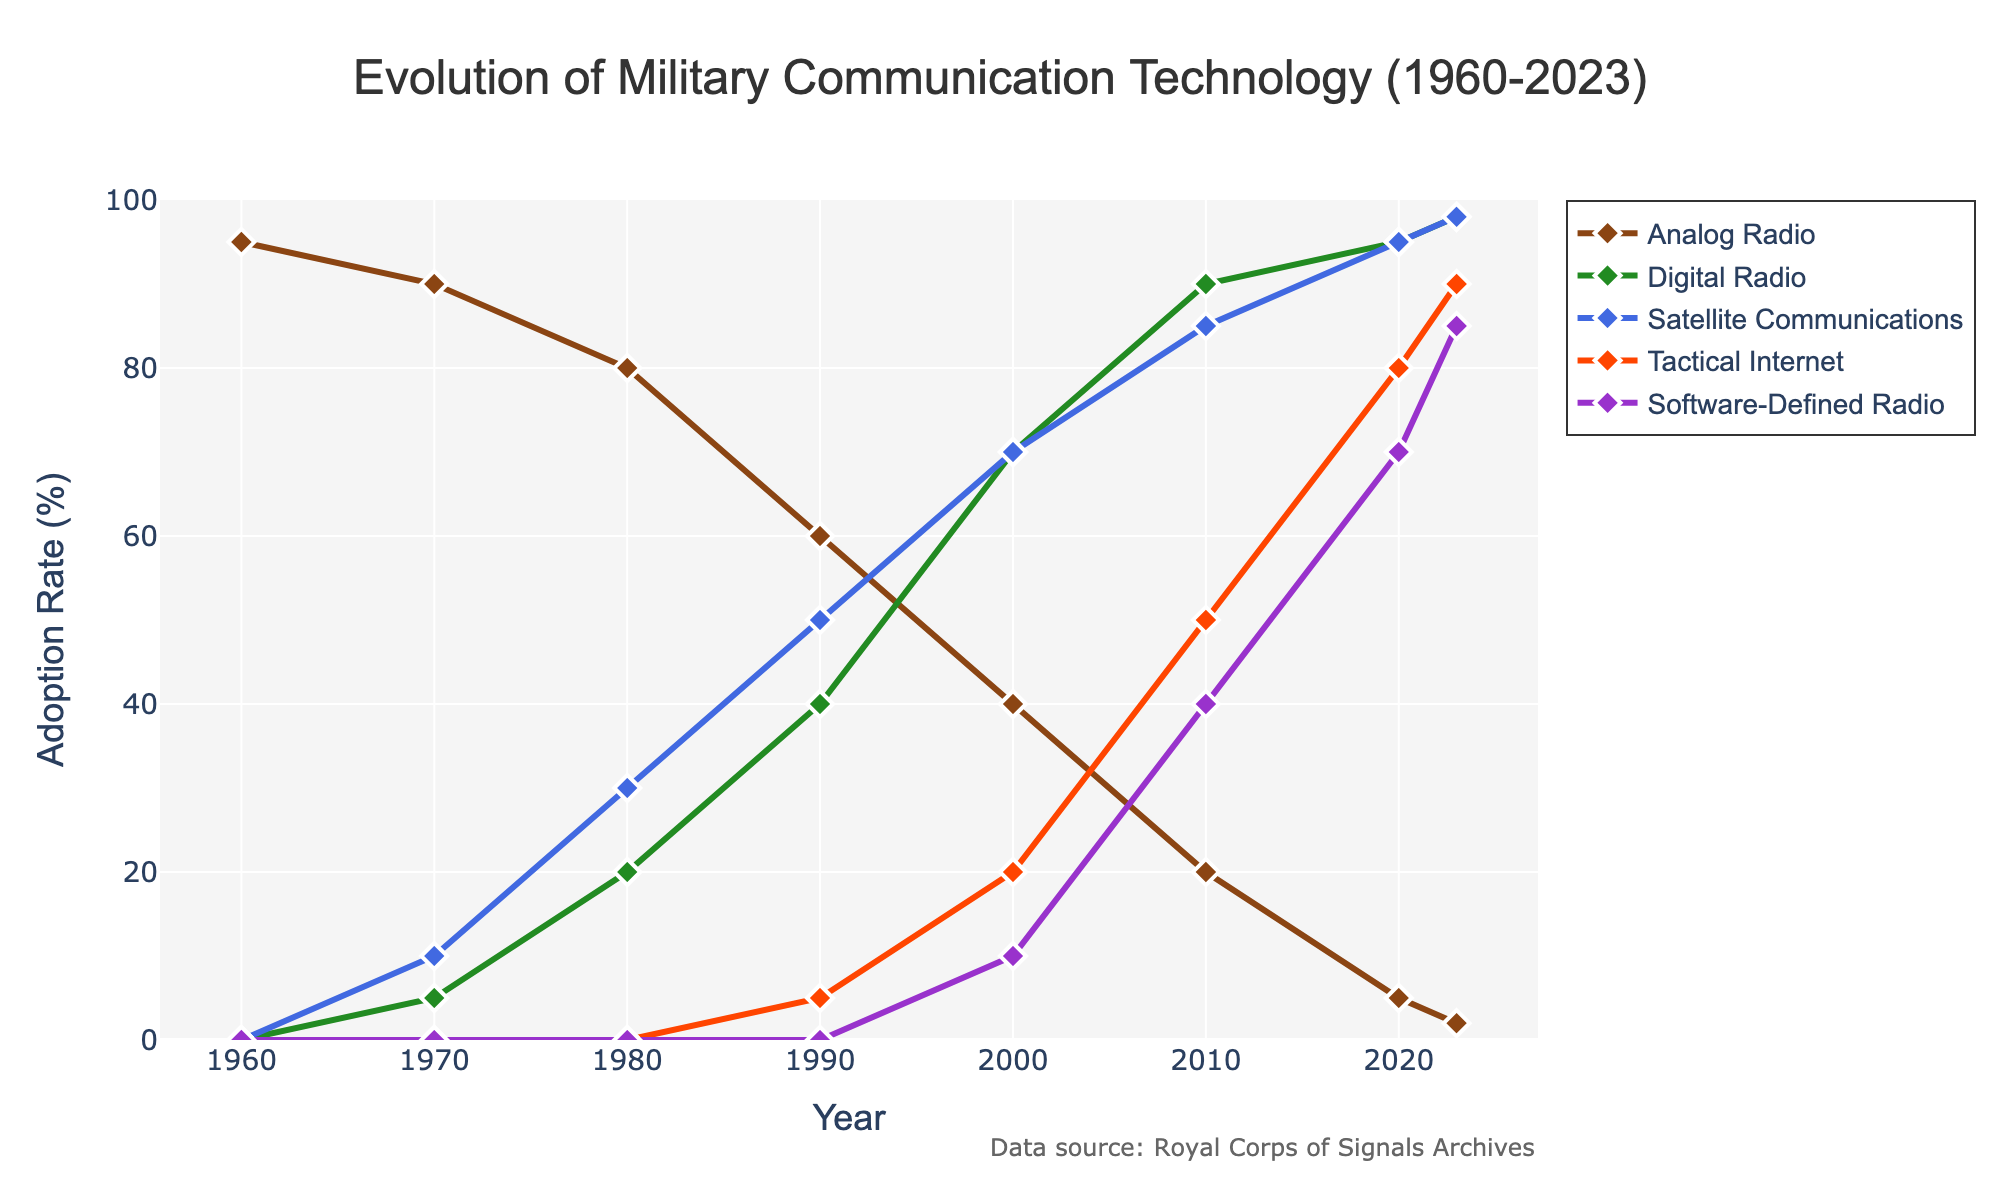What was the adoption rate of Analog Radio in 1980? To find the adoption rate of Analog Radio in 1980, locate the year 1980 on the x-axis and follow the line representing Analog Radio. The value at this point is 80%.
Answer: 80% Which communication technology had the highest adoption rate by 2023? To determine which technology had the highest adoption rate by 2023, look at the end of the lines in 2023. Both Satellite Communications and Digital Radio have the highest adoption rates at 98%.
Answer: Satellite Communications and Digital Radio Between which two consecutive decades did Satellite Communications see the biggest increase in adoption rate? To identify the biggest increase, look at the y-values for Satellite Communications from decade to decade. The largest jump is between 1970 (10%) and 1980 (30%), which is a 20% increase.
Answer: 1970 and 1980 Compare the adoption rates of Tactical Internet and Software-Defined Radio in 2010. Which one was more widely adopted? In 2010, find the lines representing Tactical Internet and Software-Defined Radio and see their y-values. Tactical Internet has a 50% adoption rate, whereas Software-Defined Radio has a 40% adoption rate. Therefore, Tactical Internet was more widely adopted.
Answer: Tactical Internet By what percentage did the adoption rate of Digital Radio increase from 2000 to 2010? To find the percentage increase from 2000 to 2010, subtract the 2000 value from the 2010 value for Digital Radio: 90% - 70% = 20%.
Answer: 20% What was the combined adoption rate of Analog Radio and Satellite Communications in 2000? Add the adoption rates of Analog Radio (40%) and Satellite Communications (70%) in 2000: 40% + 70% = 110%.
Answer: 110% Did any technology surpass the 50% adoption rate by 1990? If so, which one(s)? To check if any technology surpassed the 50% rate by 1990, look at the y-values of all technologies in 1990. Both Satellite Communications (50%) exactly reached 50% but Digital Radio (40%) and Analog Radio (60%) surpassed 50%. However, only Analog Radio clearly surpassed it.
Answer: Analog Radio How does the decline in Analog Radio adoption compare between 1960 and 2020? To determine the decline, subtract the 2020 value from the 1960 value: 95% - 5% = 90%. Therefore, Analog Radio adoption declined by 90%.
Answer: 90% Which technology saw a steady increase in adoption each decade from 1960 to 2023? To identify a steady increase, look for a line that continuously rises without decline. Digital Radio shows a steady increase from 1960 (0%) to 2023 (98%).
Answer: Digital Radio What is the adoption rate difference between Analog Radio and Software-Defined Radio in 2023? Subtract the adoption rate of Software-Defined Radio (85%) from Analog Radio (2%) in 2023: 85% - 2% = 83%.
Answer: 83% 